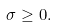<formula> <loc_0><loc_0><loc_500><loc_500>\sigma \geq 0 .</formula> 